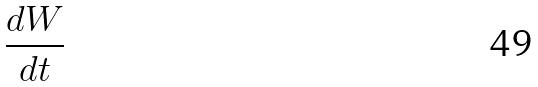Convert formula to latex. <formula><loc_0><loc_0><loc_500><loc_500>\frac { d W } { d t }</formula> 